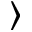<formula> <loc_0><loc_0><loc_500><loc_500>\rangle</formula> 